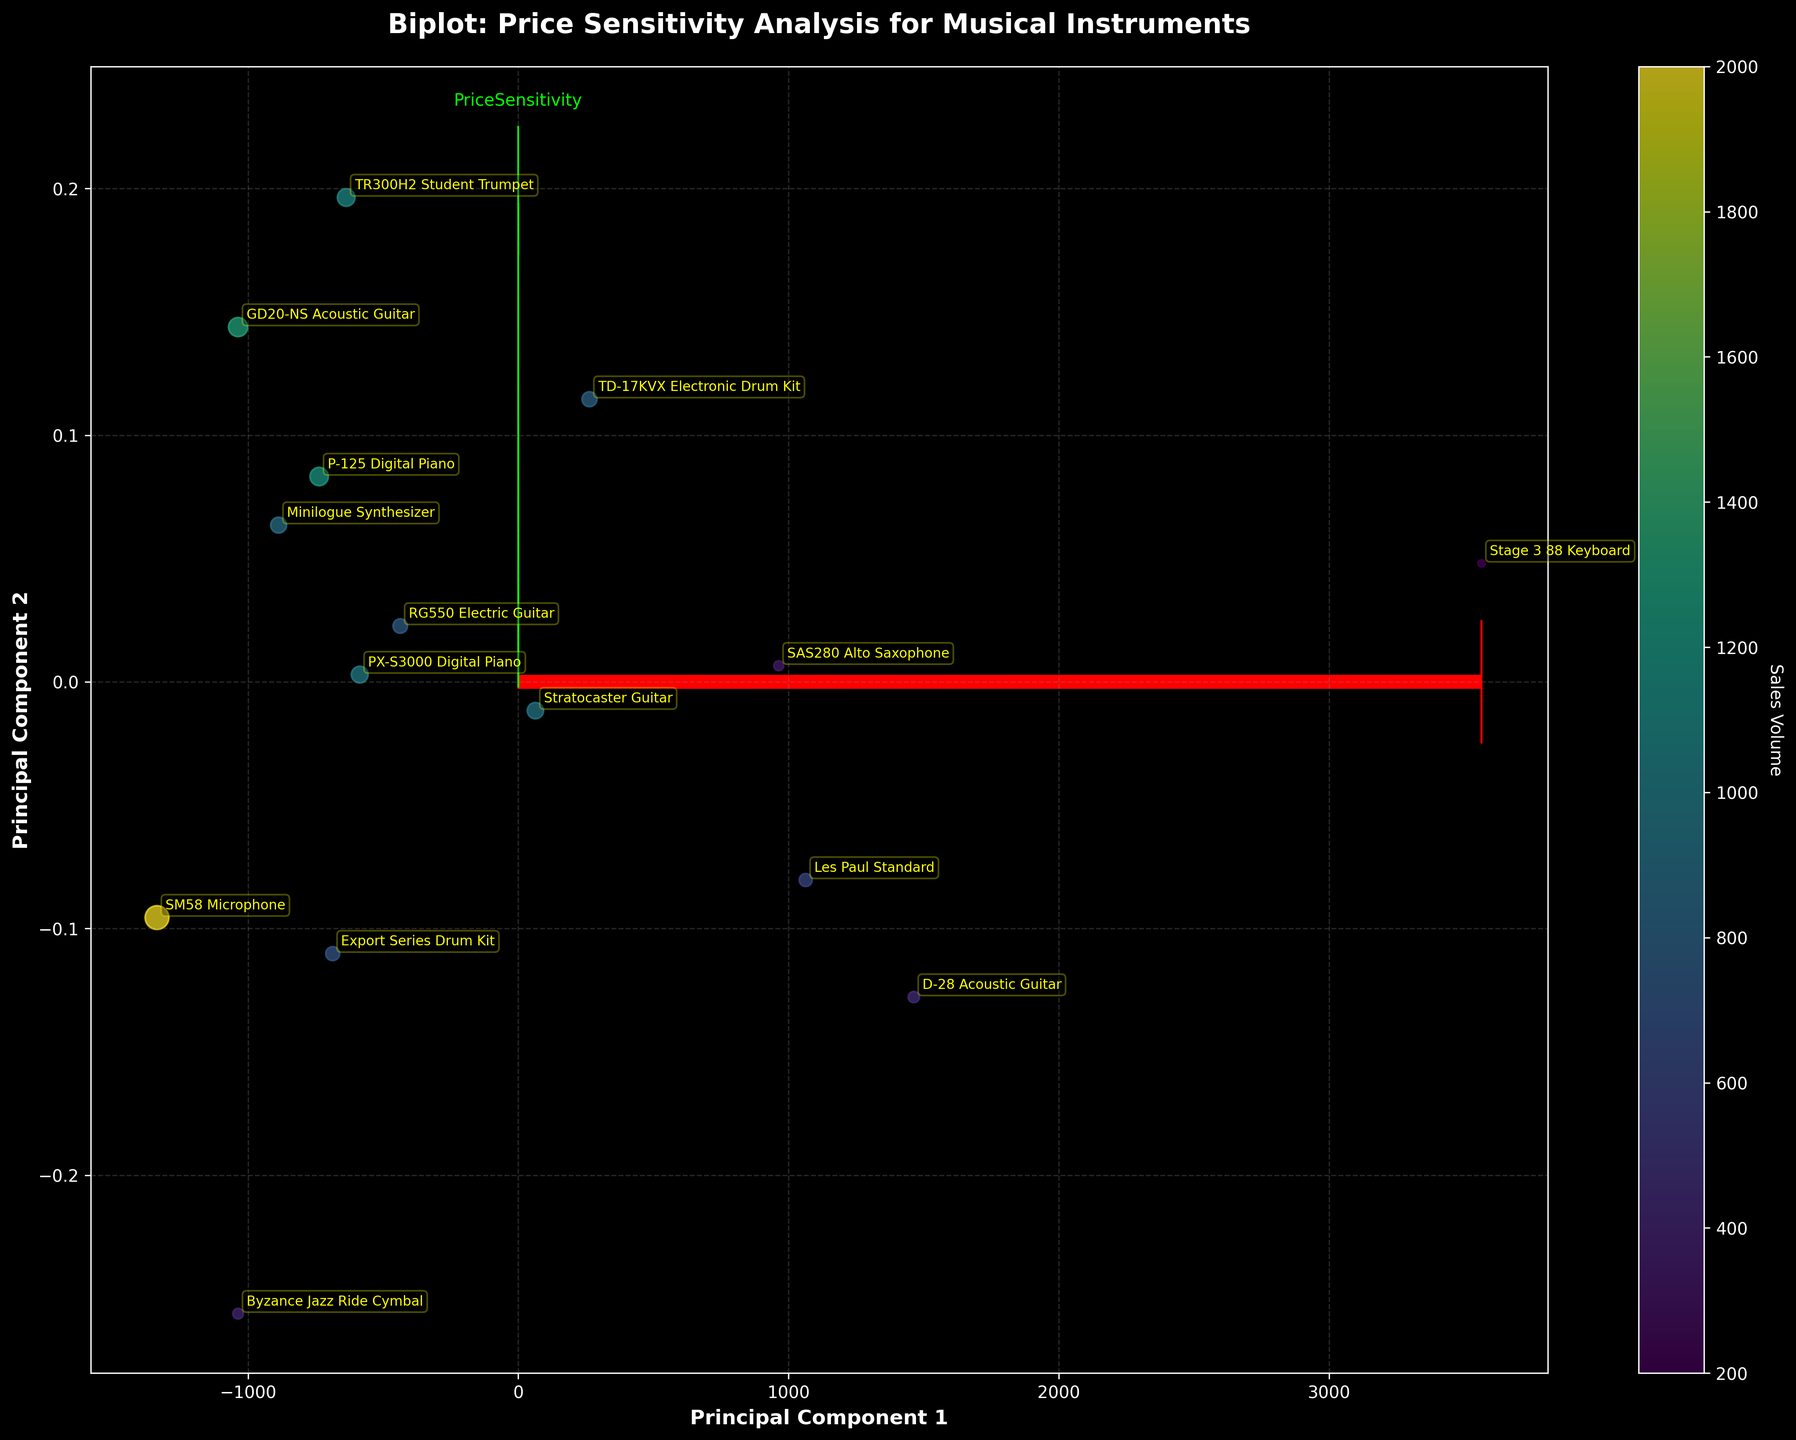How many arrows are there in the plot? By looking at the biplot, there are two arrows plotted. These arrows represent the feature vectors for 'Price' and 'PriceSensitivity'.
Answer: 2 What are the labels of the principal components on the axes? The x-axis is labeled 'Principal Component 1' and the y-axis is labeled 'Principal Component 2', as shown at the bottom and left of the biplot, respectively.
Answer: Principal Component 1, Principal Component 2 Which instrument model has the highest sales volume? By examining the sizes of the points in the biplot, we can see that the 'Shure SM58 Microphone' has the largest point size, indicating the highest sales volume.
Answer: Shure SM58 Microphone How does 'Price' influence the principal components compared to 'PriceSensitivity'? By looking at the length and direction of the arrows, the 'Price' vector extends further along Principal Component 1 while 'PriceSensitivity' extends across Principal Component 2. This suggests that 'Price' has a stronger influence on PC1 and 'PriceSensitivity' on PC2.
Answer: 'Price' influences PC1 more, 'PriceSensitivity' influences PC2 more Which two instruments are closest in terms of their principal component scores? By visually inspecting the distances between the points on the biplot, 'Korg Minilogue Synthesizer' and 'Pearl Export Series Drum Kit' appear to be very close to one another.
Answer: 'Korg Minilogue Synthesizer' and 'Pearl Export Series Drum Kit' What is the approximate sales volume of the 'Roland TD-17KVX Electronic Drum Kit' relative to its neighbors? The 'Roland TD-17KVX Electronic Drum Kit' has a moderate-sized point, smaller than 'Casio PX-S3000 Digital Piano' but larger than 'Pearl Export Series Drum Kit' nearby, indicating a moderate sales volume.
Answer: Moderate sales volume Which instrument has the lowest price sensitivity and where is it located on the plot? The 'Nord Stage 3 88 Keyboard' has the lowest price sensitivity (0.2) and it is positioned towards the leftmost part of the plot along Principal Component 1.
Answer: 'Nord Stage 3 88 Keyboard' on the leftmost part How are the 'Price' and 'PriceSensitivity' vectors different in length? Comparing the lengths of the arrows, 'Price' has a longer arrow indicating a stronger influence on the principal components than 'PriceSensitivity'.
Answer: 'Price' vector is longer What trend can you observe between price sensitivity and sales volume based on the plot? From the plot, points with larger size (higher sales volume) are often found closer to the 'PriceSensitivity' vector, indicating higher price sensitivity is associated with higher sales volumes.
Answer: Higher price sensitivity is associated with higher sales volumes Which specific musical instrument(s) are most aligned with the 'Price' direction? 'Martin D-28 Acoustic Guitar' and 'Gibson Les Paul Standard' appear most aligned with the 'Price' arrow direction on the biplot.
Answer: 'Martin D-28 Acoustic Guitar' and 'Gibson Les Paul Standard' 